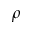Convert formula to latex. <formula><loc_0><loc_0><loc_500><loc_500>\rho</formula> 